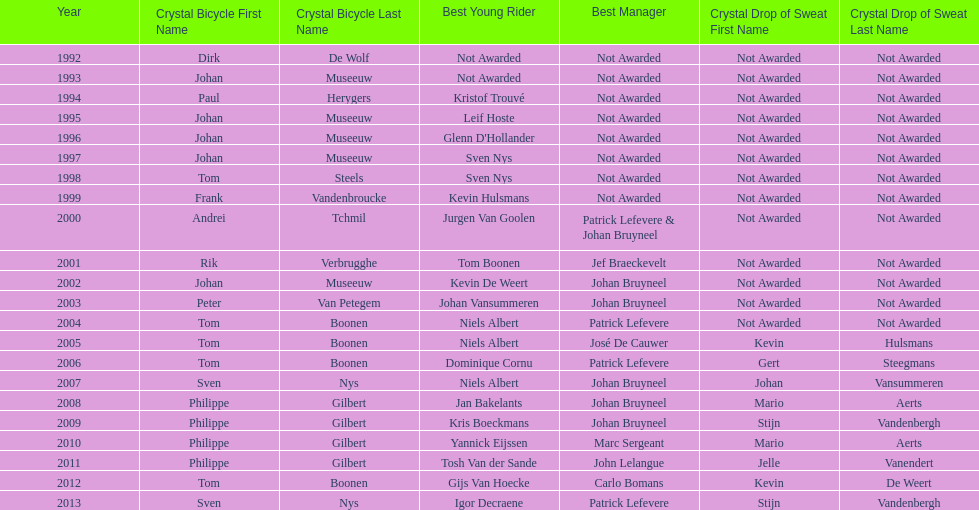What is the total number of times johan bryneel's name appears on all of these lists? 6. 